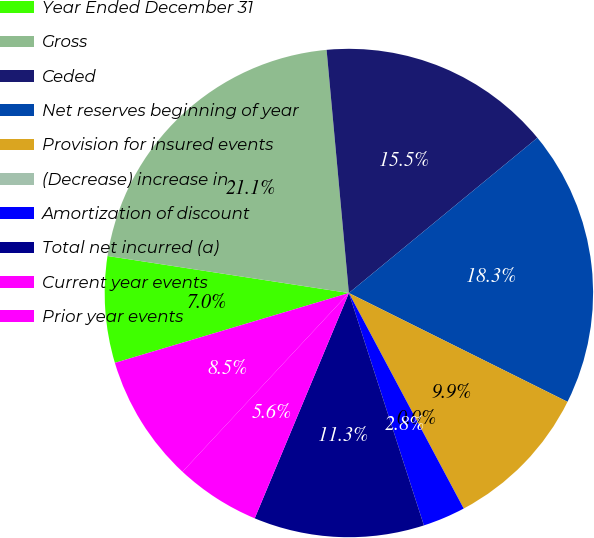Convert chart to OTSL. <chart><loc_0><loc_0><loc_500><loc_500><pie_chart><fcel>Year Ended December 31<fcel>Gross<fcel>Ceded<fcel>Net reserves beginning of year<fcel>Provision for insured events<fcel>(Decrease) increase in<fcel>Amortization of discount<fcel>Total net incurred (a)<fcel>Current year events<fcel>Prior year events<nl><fcel>7.04%<fcel>21.12%<fcel>15.49%<fcel>18.31%<fcel>9.86%<fcel>0.0%<fcel>2.82%<fcel>11.27%<fcel>5.63%<fcel>8.45%<nl></chart> 